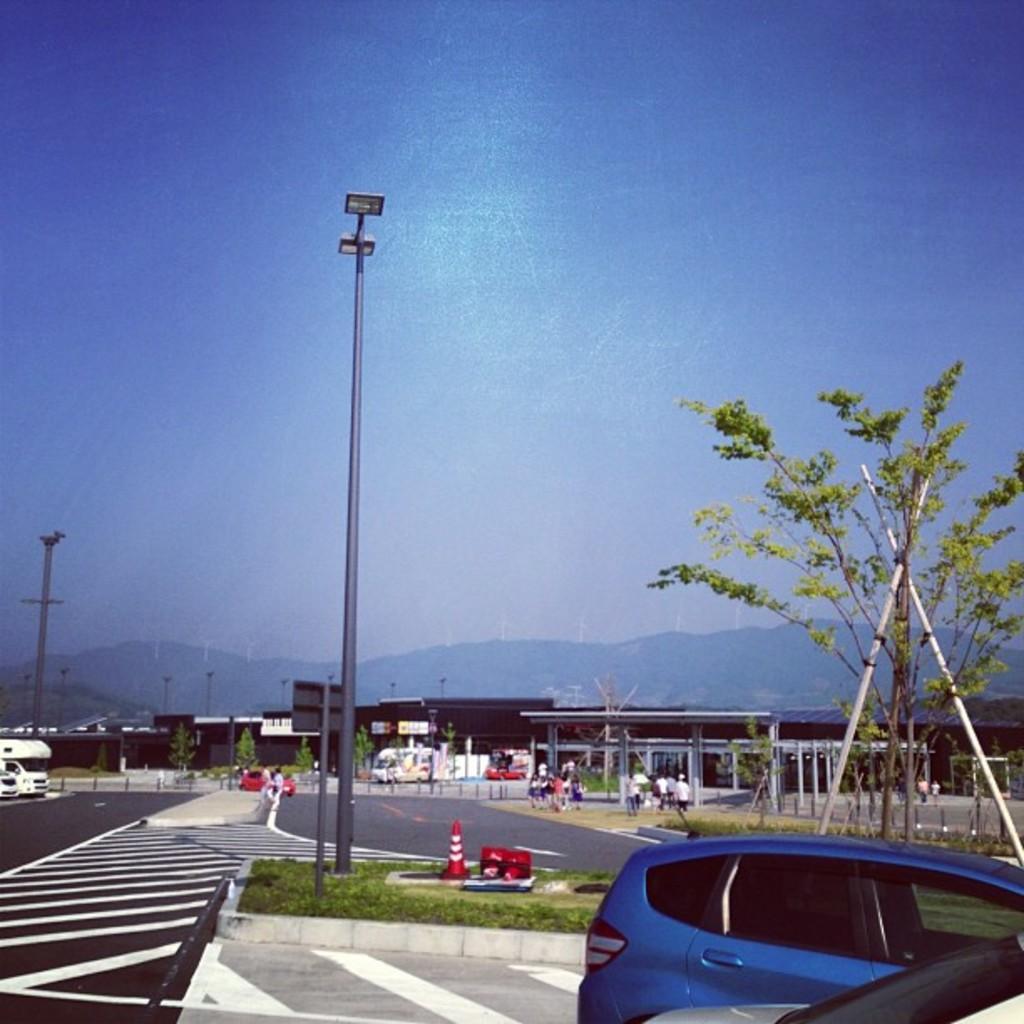Can you describe this image briefly? Sky is in blue color. Here we can see light poles, vehicles, people and trees. Far there are buildings. 